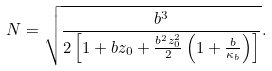Convert formula to latex. <formula><loc_0><loc_0><loc_500><loc_500>N = \sqrt { \frac { b ^ { 3 } } { 2 \left [ 1 + b z _ { 0 } + \frac { b ^ { 2 } z _ { 0 } ^ { 2 } } { 2 } \left ( 1 + \frac { b } { \kappa _ { b } } \right ) \right ] } } .</formula> 